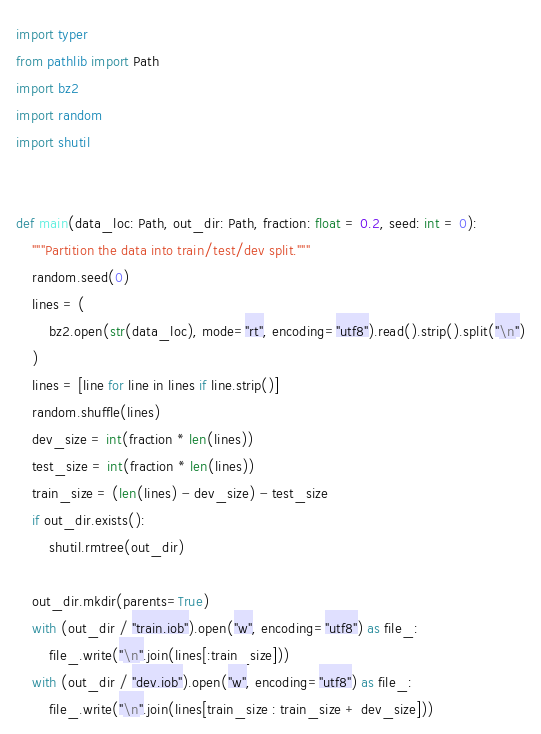Convert code to text. <code><loc_0><loc_0><loc_500><loc_500><_Python_>import typer
from pathlib import Path
import bz2
import random
import shutil


def main(data_loc: Path, out_dir: Path, fraction: float = 0.2, seed: int = 0):
    """Partition the data into train/test/dev split."""
    random.seed(0)
    lines = (
        bz2.open(str(data_loc), mode="rt", encoding="utf8").read().strip().split("\n")
    )
    lines = [line for line in lines if line.strip()]
    random.shuffle(lines)
    dev_size = int(fraction * len(lines))
    test_size = int(fraction * len(lines))
    train_size = (len(lines) - dev_size) - test_size
    if out_dir.exists():
        shutil.rmtree(out_dir)

    out_dir.mkdir(parents=True)
    with (out_dir / "train.iob").open("w", encoding="utf8") as file_:
        file_.write("\n".join(lines[:train_size]))
    with (out_dir / "dev.iob").open("w", encoding="utf8") as file_:
        file_.write("\n".join(lines[train_size : train_size + dev_size]))</code> 